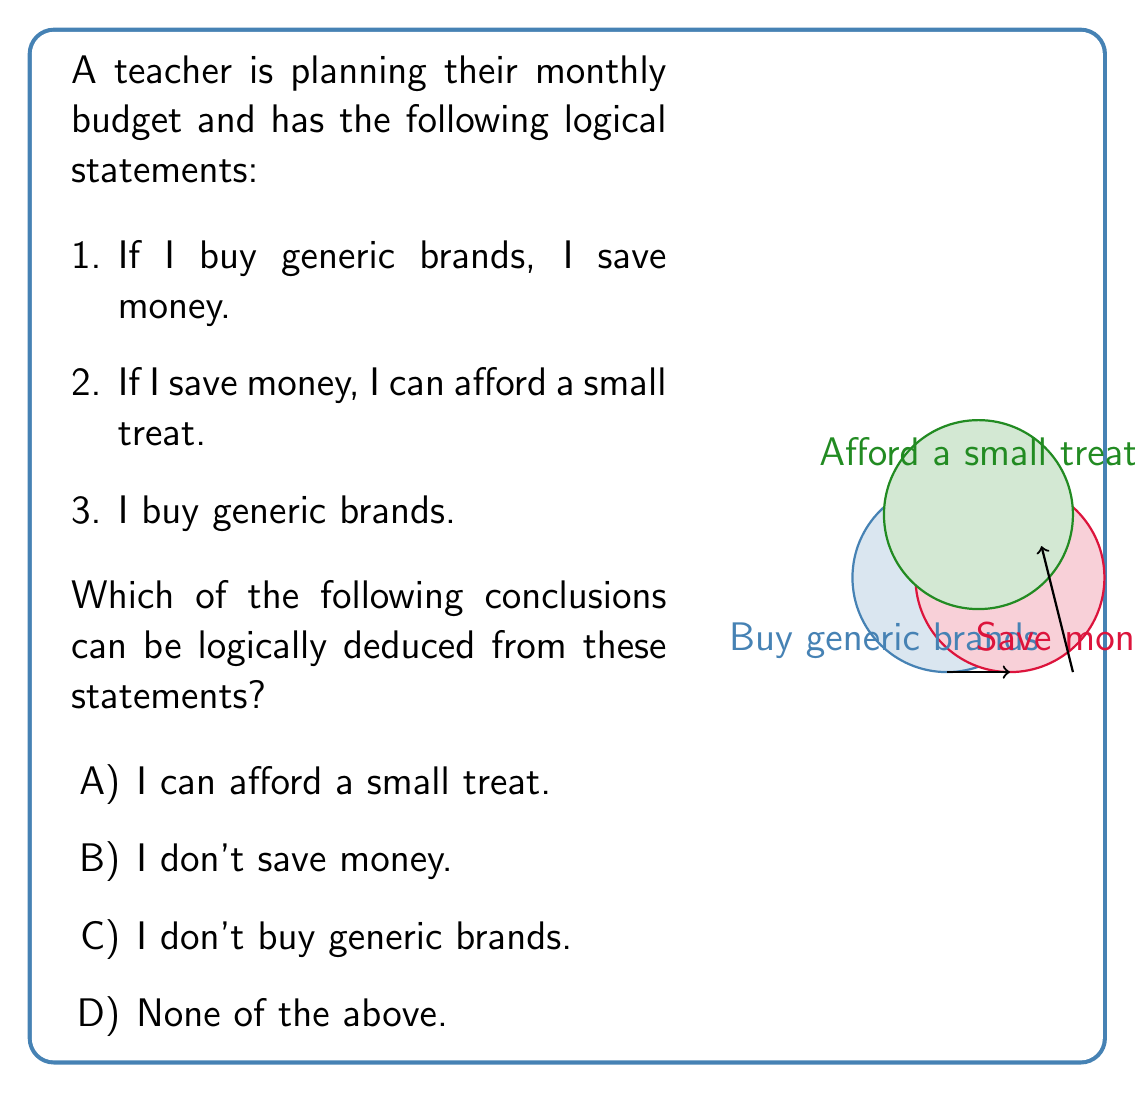Show me your answer to this math problem. Let's analyze this problem using propositional logic:

1) Let's define our propositions:
   $P$: I buy generic brands
   $Q$: I save money
   $R$: I can afford a small treat

2) We can translate the given statements into logical implications:
   Statement 1: $P \rightarrow Q$ (If I buy generic brands, then I save money)
   Statement 2: $Q \rightarrow R$ (If I save money, then I can afford a small treat)
   Statement 3: $P$ (I buy generic brands)

3) Now, let's apply the rules of inference:
   From statement 1 ($P \rightarrow Q$) and statement 3 ($P$), we can apply Modus Ponens:
   $$\frac{P \rightarrow Q, P}{Q}$$
   This allows us to conclude $Q$ (I save money).

4) Now that we've established $Q$, we can apply Modus Ponens again using statement 2 ($Q \rightarrow R$):
   $$\frac{Q \rightarrow R, Q}{R}$$
   This allows us to conclude $R$ (I can afford a small treat).

5) Therefore, the logical conclusion we can draw from these statements is that "I can afford a small treat" (option A).

Options B and C contradict our given information and derived conclusions, so they cannot be correct. Option D is also incorrect because we were able to make a valid logical deduction.
Answer: A 